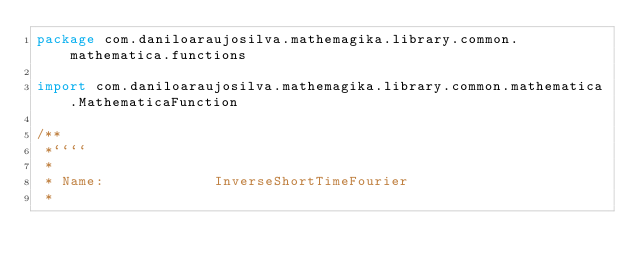Convert code to text. <code><loc_0><loc_0><loc_500><loc_500><_Kotlin_>package com.daniloaraujosilva.mathemagika.library.common.mathematica.functions

import com.daniloaraujosilva.mathemagika.library.common.mathematica.MathematicaFunction

/**
 *````
 *
 * Name:             InverseShortTimeFourier
 *</code> 